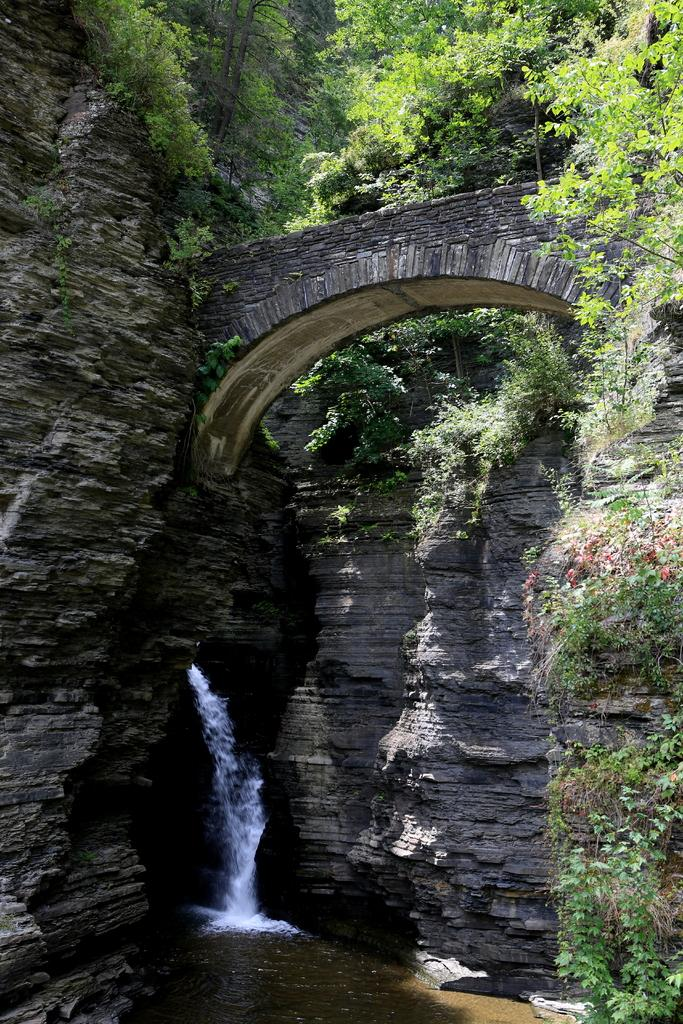What natural element can be seen in the image? Water is visible in the image. What type of vegetation is present in the image? There are trees in the image. What type of geological formation can be seen in the image? There are rocks in the image. What structure is present in the image, and what is its purpose? There is a bridge in the image, and it is positioned over the water. What type of metal can be seen being used by the secretary in the image? There is no secretary present in the image. What type of clothing is the beggar wearing in the image? There is no beggar present in the image. 